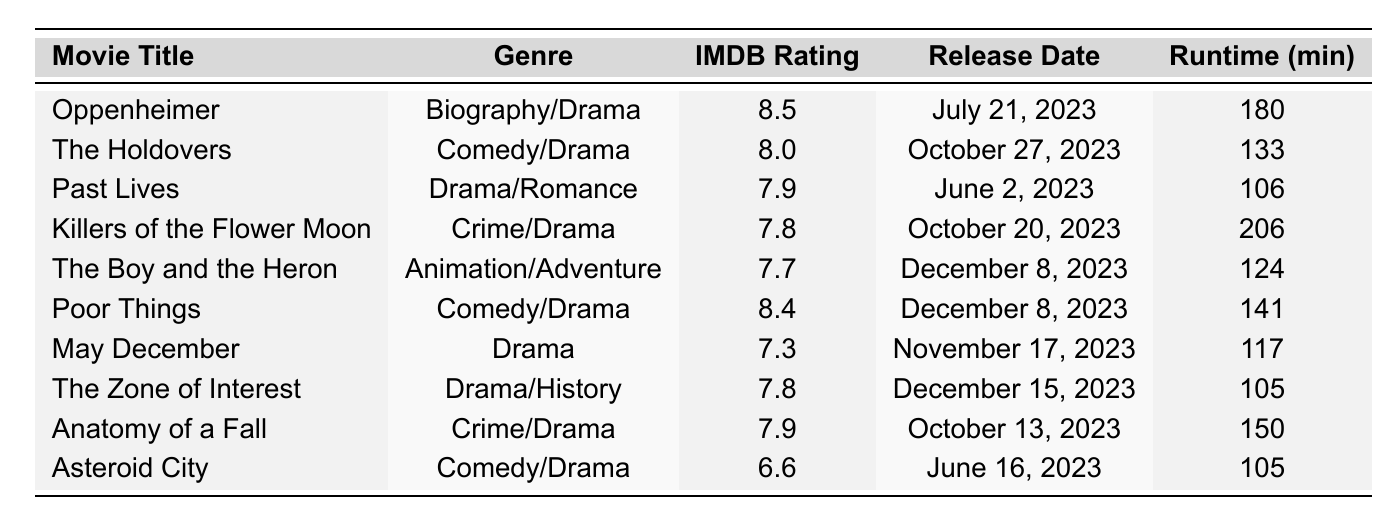What is the highest IMDB rating among the movies listed? The highest IMDB rating in the table is found by comparing the ratings of all movies. "Oppenheimer" has the highest rating of 8.5.
Answer: 8.5 Which movie has the longest runtime? By reviewing the Runtime column, "Killers of the Flower Moon" has the longest runtime listed at 206 minutes.
Answer: 206 Are there any comedy/drama movies with an IMDB rating above 8? The table shows two movies that fit this category: "The Holdovers" (8.0) and "Poor Things" (8.4). "Poor Things" has an IMDB rating above 8.
Answer: Yes What is the average IMDB rating of all the movies? The IMDB ratings are 8.5, 8.0, 7.9, 7.8, 7.7, 8.4, 7.3, 7.8, 7.9, and 6.6. Summing these gives 78.9 and dividing by 10 (the number of movies) gives an average of 7.89.
Answer: 7.89 Which movie released in October 2023 has the highest rating? From the October releases listed ("The Holdovers", "Killers of the Flower Moon", and "Anatomy of a Fall"), "The Holdovers" has an IMDB rating of 8.0 while the other two have ratings of 7.8 and 7.9, respectively. So, "Anatomy of a Fall" has the highest rating with 7.9.
Answer: Anatomy of a Fall Is there a movie categorized as both "Drama" and "Biography"? The "Biography/Drama" genre is present in "Oppenheimer", which combines both categories.
Answer: Yes How many movies in the table have a runtime of 130 minutes or more? The movies with runtimes of 130 minutes or more are "Oppenheimer" (180), "Killers of the Flower Moon" (206), "Poor Things" (141), and "Anatomy of a Fall" (150). That totals 4 movies.
Answer: 4 Which movie released first: "Past Lives" or "Asteroid City"? "Past Lives" was released on June 2, 2023, while "Asteroid City" was released on June 16, 2023. Since June 2 is earlier, "Past Lives" was released first.
Answer: Past Lives What is the genre of "The Boy and the Heron"? The genre listed for "The Boy and the Heron" is "Animation/Adventure" according to the table.
Answer: Animation/Adventure How many films have a rating below 7.5? The films with ratings below 7.5 are "May December" (7.3) and "Asteroid City" (6.6), totaling 2 films.
Answer: 2 What is the distribution of genres among the movies listed? Looking at the data, the genres are: Biography/Drama (1), Comedy/Drama (3), Drama/Romance (1), Crime/Drama (2), Animation/Adventure (1), Drama (1), Drama/History (1). The distribution across genres reflects a mix of drama-oriented films dominating the list.
Answer: 7 genres (varied distribution) 